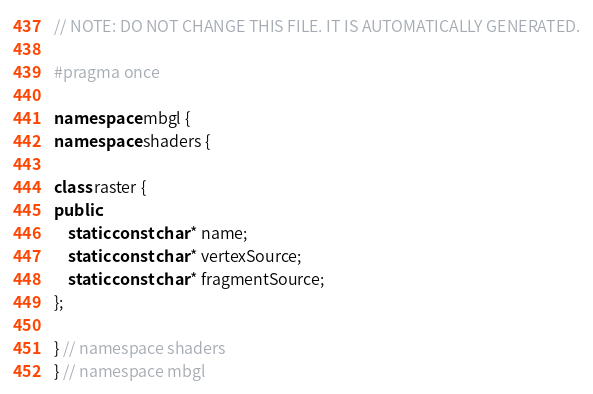Convert code to text. <code><loc_0><loc_0><loc_500><loc_500><_C++_>// NOTE: DO NOT CHANGE THIS FILE. IT IS AUTOMATICALLY GENERATED.

#pragma once

namespace mbgl {
namespace shaders {

class raster {
public:
    static const char* name;
    static const char* vertexSource;
    static const char* fragmentSource;
};

} // namespace shaders
} // namespace mbgl
</code> 